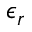Convert formula to latex. <formula><loc_0><loc_0><loc_500><loc_500>\epsilon _ { r }</formula> 